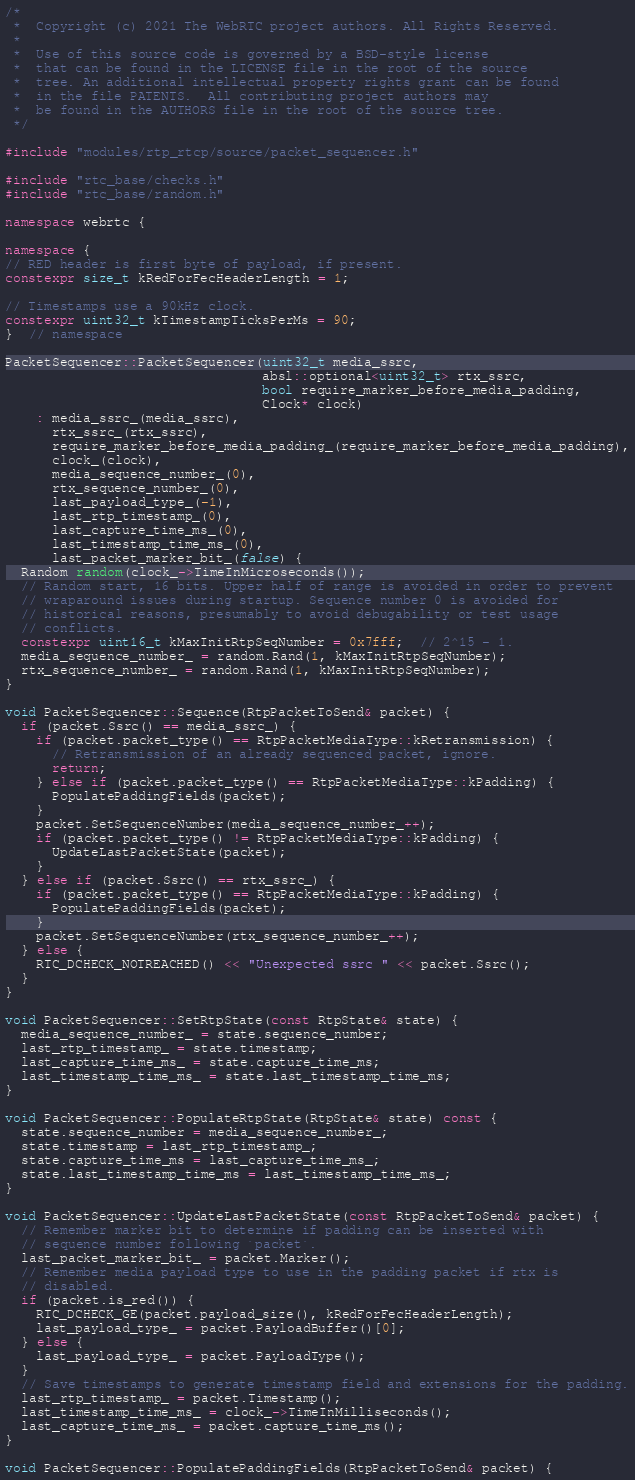Convert code to text. <code><loc_0><loc_0><loc_500><loc_500><_C++_>/*
 *  Copyright (c) 2021 The WebRTC project authors. All Rights Reserved.
 *
 *  Use of this source code is governed by a BSD-style license
 *  that can be found in the LICENSE file in the root of the source
 *  tree. An additional intellectual property rights grant can be found
 *  in the file PATENTS.  All contributing project authors may
 *  be found in the AUTHORS file in the root of the source tree.
 */

#include "modules/rtp_rtcp/source/packet_sequencer.h"

#include "rtc_base/checks.h"
#include "rtc_base/random.h"

namespace webrtc {

namespace {
// RED header is first byte of payload, if present.
constexpr size_t kRedForFecHeaderLength = 1;

// Timestamps use a 90kHz clock.
constexpr uint32_t kTimestampTicksPerMs = 90;
}  // namespace

PacketSequencer::PacketSequencer(uint32_t media_ssrc,
                                 absl::optional<uint32_t> rtx_ssrc,
                                 bool require_marker_before_media_padding,
                                 Clock* clock)
    : media_ssrc_(media_ssrc),
      rtx_ssrc_(rtx_ssrc),
      require_marker_before_media_padding_(require_marker_before_media_padding),
      clock_(clock),
      media_sequence_number_(0),
      rtx_sequence_number_(0),
      last_payload_type_(-1),
      last_rtp_timestamp_(0),
      last_capture_time_ms_(0),
      last_timestamp_time_ms_(0),
      last_packet_marker_bit_(false) {
  Random random(clock_->TimeInMicroseconds());
  // Random start, 16 bits. Upper half of range is avoided in order to prevent
  // wraparound issues during startup. Sequence number 0 is avoided for
  // historical reasons, presumably to avoid debugability or test usage
  // conflicts.
  constexpr uint16_t kMaxInitRtpSeqNumber = 0x7fff;  // 2^15 - 1.
  media_sequence_number_ = random.Rand(1, kMaxInitRtpSeqNumber);
  rtx_sequence_number_ = random.Rand(1, kMaxInitRtpSeqNumber);
}

void PacketSequencer::Sequence(RtpPacketToSend& packet) {
  if (packet.Ssrc() == media_ssrc_) {
    if (packet.packet_type() == RtpPacketMediaType::kRetransmission) {
      // Retransmission of an already sequenced packet, ignore.
      return;
    } else if (packet.packet_type() == RtpPacketMediaType::kPadding) {
      PopulatePaddingFields(packet);
    }
    packet.SetSequenceNumber(media_sequence_number_++);
    if (packet.packet_type() != RtpPacketMediaType::kPadding) {
      UpdateLastPacketState(packet);
    }
  } else if (packet.Ssrc() == rtx_ssrc_) {
    if (packet.packet_type() == RtpPacketMediaType::kPadding) {
      PopulatePaddingFields(packet);
    }
    packet.SetSequenceNumber(rtx_sequence_number_++);
  } else {
    RTC_DCHECK_NOTREACHED() << "Unexpected ssrc " << packet.Ssrc();
  }
}

void PacketSequencer::SetRtpState(const RtpState& state) {
  media_sequence_number_ = state.sequence_number;
  last_rtp_timestamp_ = state.timestamp;
  last_capture_time_ms_ = state.capture_time_ms;
  last_timestamp_time_ms_ = state.last_timestamp_time_ms;
}

void PacketSequencer::PopulateRtpState(RtpState& state) const {
  state.sequence_number = media_sequence_number_;
  state.timestamp = last_rtp_timestamp_;
  state.capture_time_ms = last_capture_time_ms_;
  state.last_timestamp_time_ms = last_timestamp_time_ms_;
}

void PacketSequencer::UpdateLastPacketState(const RtpPacketToSend& packet) {
  // Remember marker bit to determine if padding can be inserted with
  // sequence number following `packet`.
  last_packet_marker_bit_ = packet.Marker();
  // Remember media payload type to use in the padding packet if rtx is
  // disabled.
  if (packet.is_red()) {
    RTC_DCHECK_GE(packet.payload_size(), kRedForFecHeaderLength);
    last_payload_type_ = packet.PayloadBuffer()[0];
  } else {
    last_payload_type_ = packet.PayloadType();
  }
  // Save timestamps to generate timestamp field and extensions for the padding.
  last_rtp_timestamp_ = packet.Timestamp();
  last_timestamp_time_ms_ = clock_->TimeInMilliseconds();
  last_capture_time_ms_ = packet.capture_time_ms();
}

void PacketSequencer::PopulatePaddingFields(RtpPacketToSend& packet) {</code> 